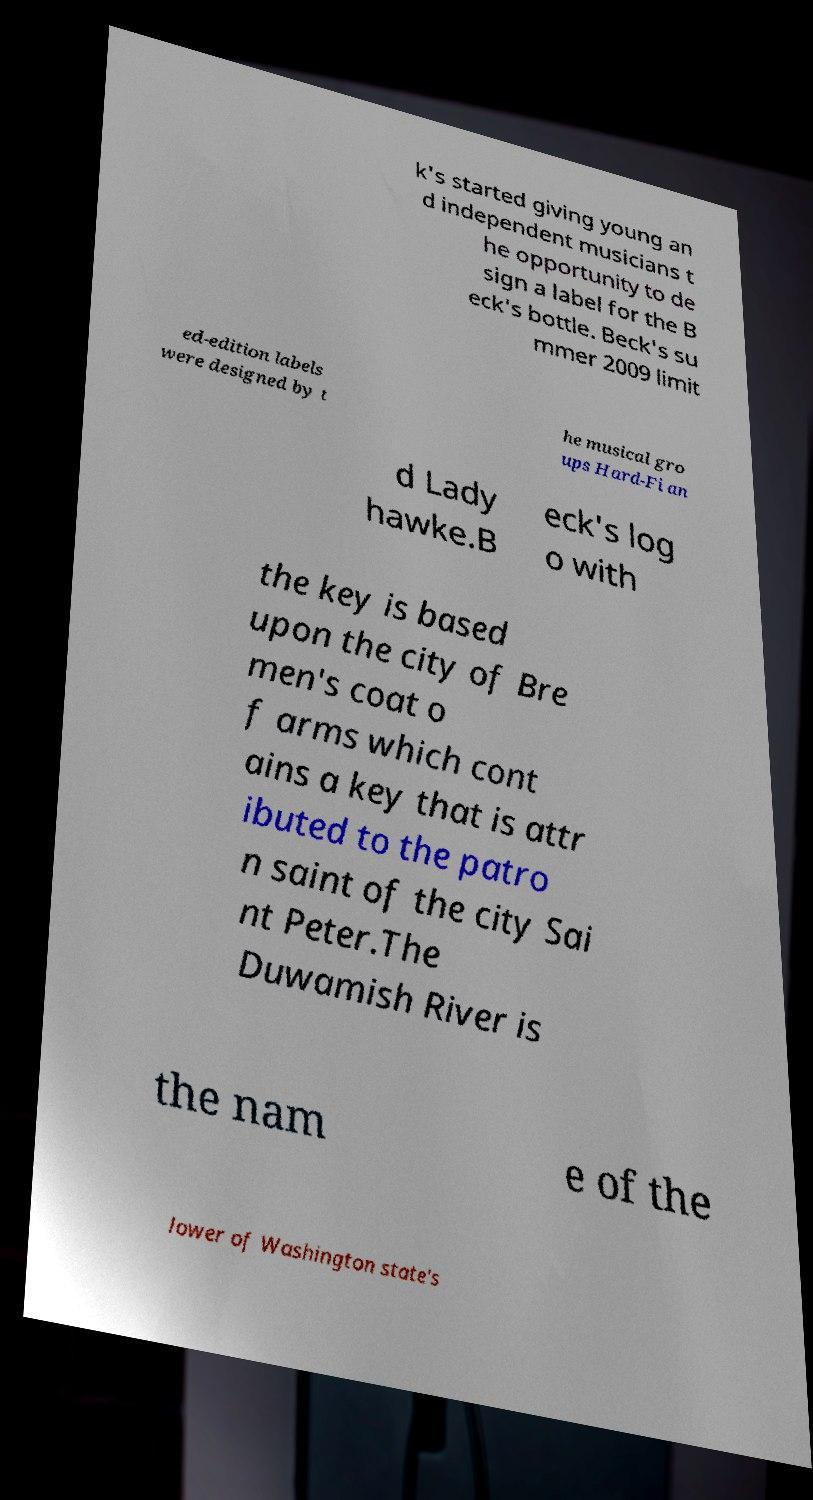There's text embedded in this image that I need extracted. Can you transcribe it verbatim? k's started giving young an d independent musicians t he opportunity to de sign a label for the B eck's bottle. Beck's su mmer 2009 limit ed-edition labels were designed by t he musical gro ups Hard-Fi an d Lady hawke.B eck's log o with the key is based upon the city of Bre men's coat o f arms which cont ains a key that is attr ibuted to the patro n saint of the city Sai nt Peter.The Duwamish River is the nam e of the lower of Washington state's 